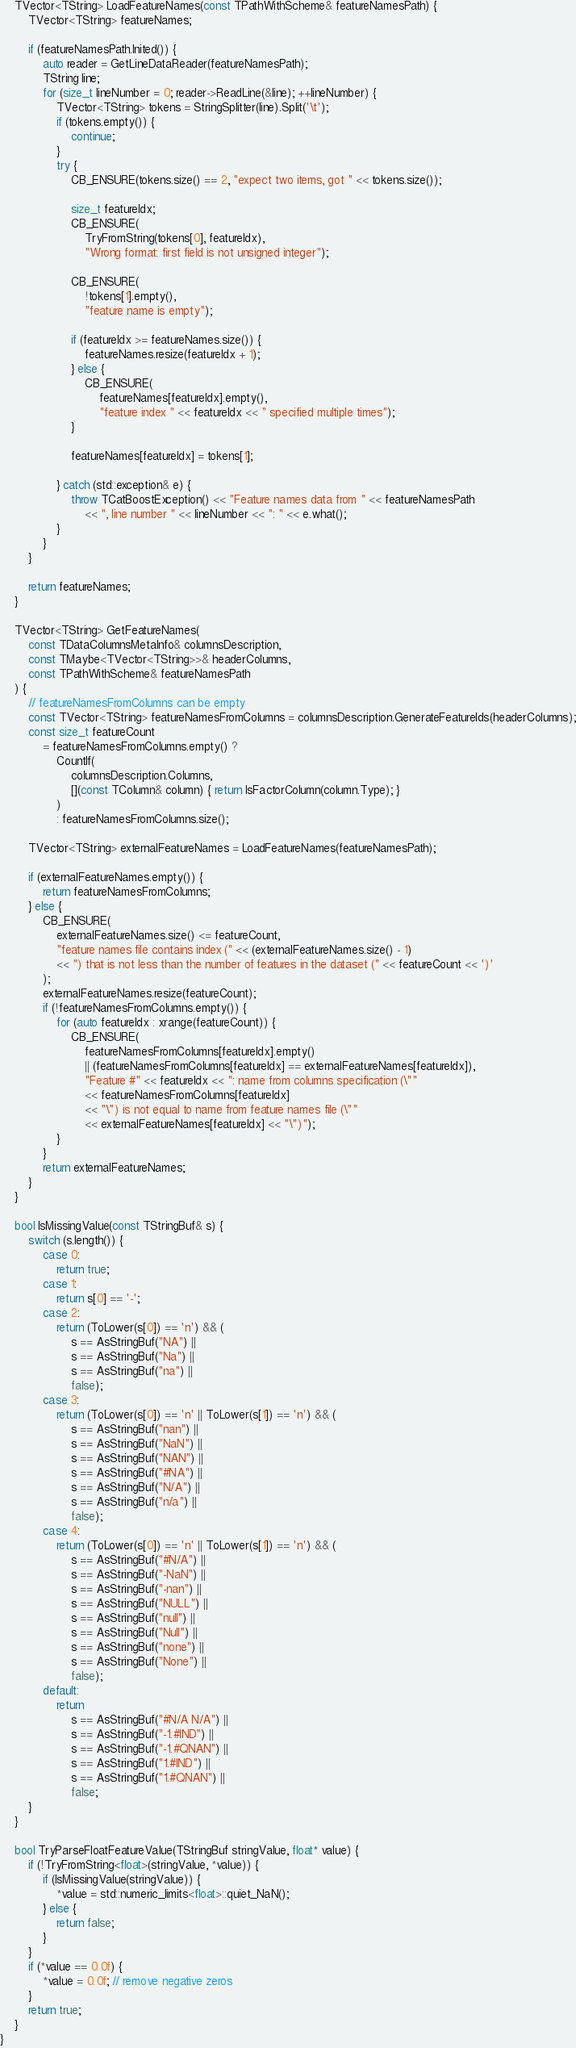Convert code to text. <code><loc_0><loc_0><loc_500><loc_500><_C++_>    TVector<TString> LoadFeatureNames(const TPathWithScheme& featureNamesPath) {
        TVector<TString> featureNames;

        if (featureNamesPath.Inited()) {
            auto reader = GetLineDataReader(featureNamesPath);
            TString line;
            for (size_t lineNumber = 0; reader->ReadLine(&line); ++lineNumber) {
                TVector<TString> tokens = StringSplitter(line).Split('\t');
                if (tokens.empty()) {
                    continue;
                }
                try {
                    CB_ENSURE(tokens.size() == 2, "expect two items, got " << tokens.size());

                    size_t featureIdx;
                    CB_ENSURE(
                        TryFromString(tokens[0], featureIdx),
                        "Wrong format: first field is not unsigned integer");

                    CB_ENSURE(
                        !tokens[1].empty(),
                        "feature name is empty");

                    if (featureIdx >= featureNames.size()) {
                        featureNames.resize(featureIdx + 1);
                    } else {
                        CB_ENSURE(
                            featureNames[featureIdx].empty(),
                            "feature index " << featureIdx << " specified multiple times");
                    }

                    featureNames[featureIdx] = tokens[1];

                } catch (std::exception& e) {
                    throw TCatBoostException() << "Feature names data from " << featureNamesPath
                        << ", line number " << lineNumber << ": " << e.what();
                }
            }
        }

        return featureNames;
    }

    TVector<TString> GetFeatureNames(
        const TDataColumnsMetaInfo& columnsDescription,
        const TMaybe<TVector<TString>>& headerColumns,
        const TPathWithScheme& featureNamesPath
    ) {
        // featureNamesFromColumns can be empty
        const TVector<TString> featureNamesFromColumns = columnsDescription.GenerateFeatureIds(headerColumns);
        const size_t featureCount
            = featureNamesFromColumns.empty() ?
                CountIf(
                    columnsDescription.Columns,
                    [](const TColumn& column) { return IsFactorColumn(column.Type); }
                )
                : featureNamesFromColumns.size();

        TVector<TString> externalFeatureNames = LoadFeatureNames(featureNamesPath);

        if (externalFeatureNames.empty()) {
            return featureNamesFromColumns;
        } else {
            CB_ENSURE(
                externalFeatureNames.size() <= featureCount,
                "feature names file contains index (" << (externalFeatureNames.size() - 1)
                << ") that is not less than the number of features in the dataset (" << featureCount << ')'
            );
            externalFeatureNames.resize(featureCount);
            if (!featureNamesFromColumns.empty()) {
                for (auto featureIdx : xrange(featureCount)) {
                    CB_ENSURE(
                        featureNamesFromColumns[featureIdx].empty()
                        || (featureNamesFromColumns[featureIdx] == externalFeatureNames[featureIdx]),
                        "Feature #" << featureIdx << ": name from columns specification (\""
                        << featureNamesFromColumns[featureIdx]
                        << "\") is not equal to name from feature names file (\""
                        << externalFeatureNames[featureIdx] << "\")");
                }
            }
            return externalFeatureNames;
        }
    }

    bool IsMissingValue(const TStringBuf& s) {
        switch (s.length()) {
            case 0:
                return true;
            case 1:
                return s[0] == '-';
            case 2:
                return (ToLower(s[0]) == 'n') && (
                    s == AsStringBuf("NA") ||
                    s == AsStringBuf("Na") ||
                    s == AsStringBuf("na") ||
                    false);
            case 3:
                return (ToLower(s[0]) == 'n' || ToLower(s[1]) == 'n') && (
                    s == AsStringBuf("nan") ||
                    s == AsStringBuf("NaN") ||
                    s == AsStringBuf("NAN") ||
                    s == AsStringBuf("#NA") ||
                    s == AsStringBuf("N/A") ||
                    s == AsStringBuf("n/a") ||
                    false);
            case 4:
                return (ToLower(s[0]) == 'n' || ToLower(s[1]) == 'n') && (
                    s == AsStringBuf("#N/A") ||
                    s == AsStringBuf("-NaN") ||
                    s == AsStringBuf("-nan") ||
                    s == AsStringBuf("NULL") ||
                    s == AsStringBuf("null") ||
                    s == AsStringBuf("Null") ||
                    s == AsStringBuf("none") ||
                    s == AsStringBuf("None") ||
                    false);
            default:
                return
                    s == AsStringBuf("#N/A N/A") ||
                    s == AsStringBuf("-1.#IND") ||
                    s == AsStringBuf("-1.#QNAN") ||
                    s == AsStringBuf("1.#IND") ||
                    s == AsStringBuf("1.#QNAN") ||
                    false;
        }
    }

    bool TryParseFloatFeatureValue(TStringBuf stringValue, float* value) {
        if (!TryFromString<float>(stringValue, *value)) {
            if (IsMissingValue(stringValue)) {
                *value = std::numeric_limits<float>::quiet_NaN();
            } else {
                return false;
            }
        }
        if (*value == 0.0f) {
            *value = 0.0f; // remove negative zeros
        }
        return true;
    }
}
</code> 